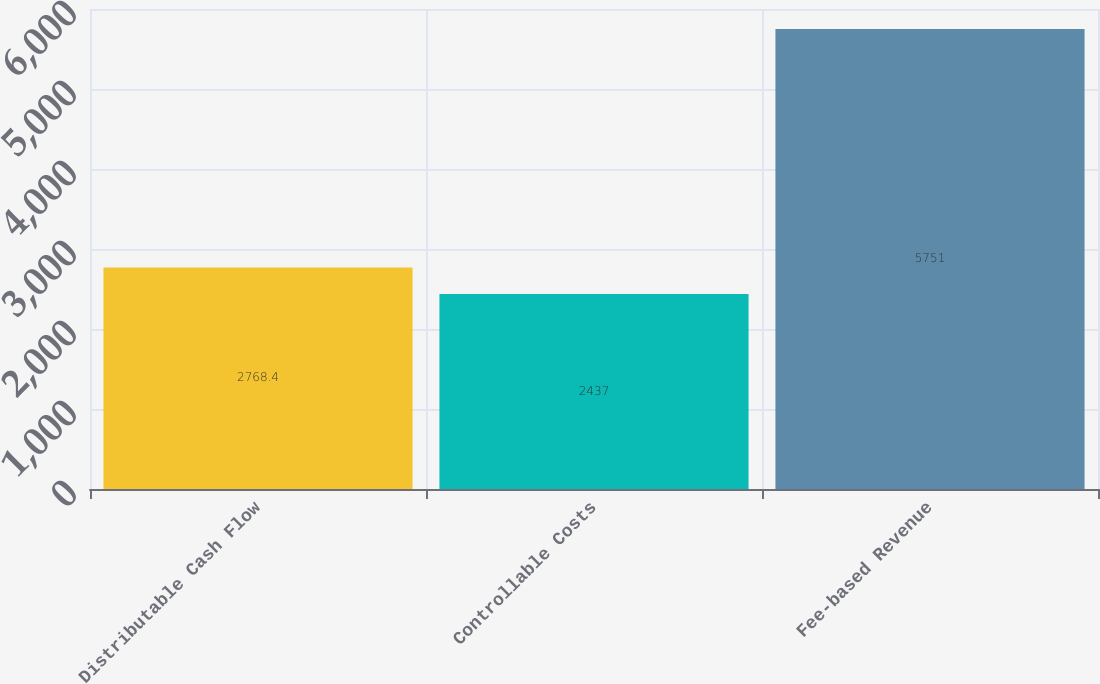Convert chart. <chart><loc_0><loc_0><loc_500><loc_500><bar_chart><fcel>Distributable Cash Flow<fcel>Controllable Costs<fcel>Fee-based Revenue<nl><fcel>2768.4<fcel>2437<fcel>5751<nl></chart> 